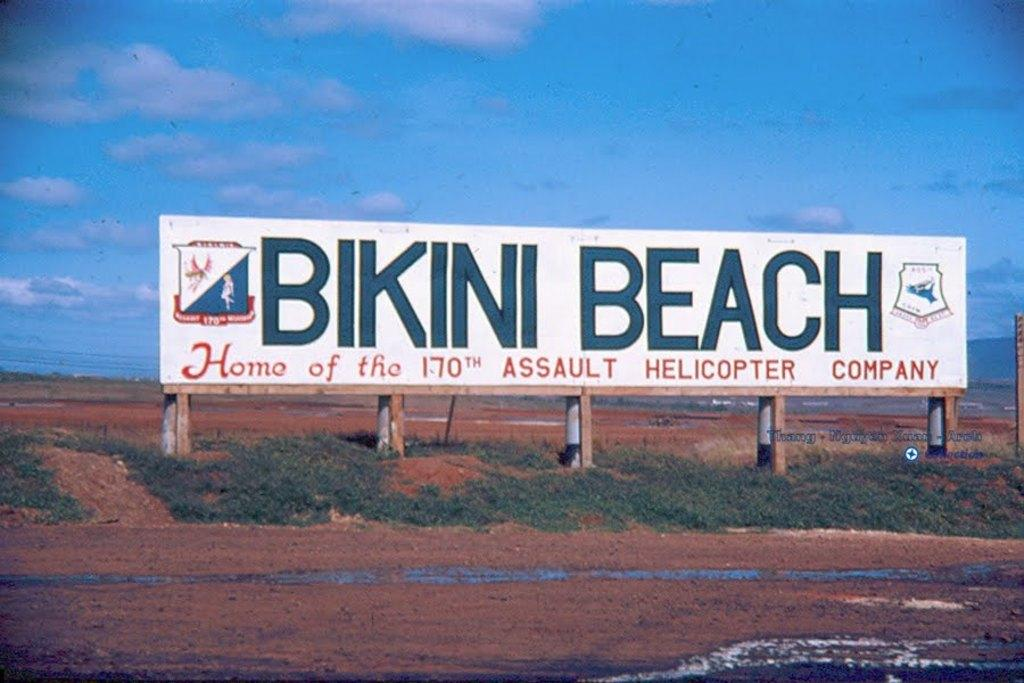Provide a one-sentence caption for the provided image. Billboard on the side of the road that says Bikini Beach. 